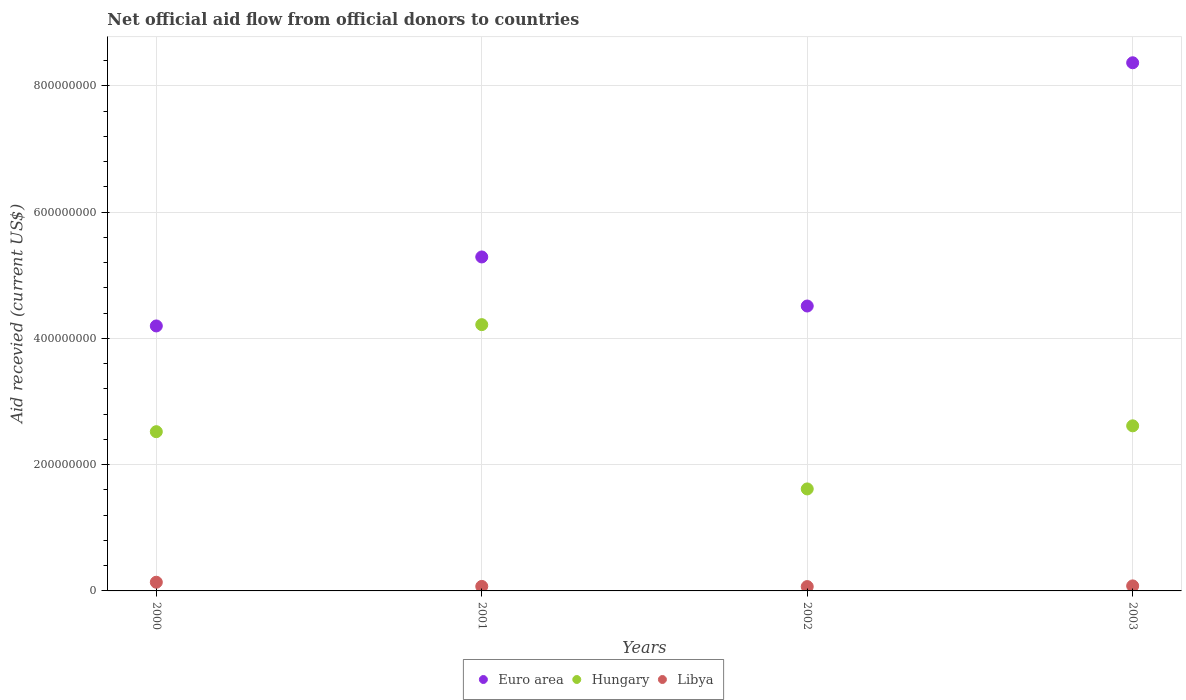How many different coloured dotlines are there?
Ensure brevity in your answer.  3. What is the total aid received in Libya in 2003?
Provide a short and direct response. 7.95e+06. Across all years, what is the maximum total aid received in Euro area?
Ensure brevity in your answer.  8.36e+08. Across all years, what is the minimum total aid received in Libya?
Offer a terse response. 6.88e+06. What is the total total aid received in Hungary in the graph?
Provide a succinct answer. 1.10e+09. What is the difference between the total aid received in Euro area in 2002 and that in 2003?
Provide a short and direct response. -3.85e+08. What is the difference between the total aid received in Euro area in 2003 and the total aid received in Hungary in 2000?
Provide a short and direct response. 5.84e+08. What is the average total aid received in Libya per year?
Ensure brevity in your answer.  8.93e+06. In the year 2000, what is the difference between the total aid received in Libya and total aid received in Hungary?
Keep it short and to the point. -2.38e+08. What is the ratio of the total aid received in Euro area in 2001 to that in 2003?
Your response must be concise. 0.63. Is the difference between the total aid received in Libya in 2000 and 2002 greater than the difference between the total aid received in Hungary in 2000 and 2002?
Keep it short and to the point. No. What is the difference between the highest and the second highest total aid received in Euro area?
Your answer should be compact. 3.08e+08. What is the difference between the highest and the lowest total aid received in Euro area?
Keep it short and to the point. 4.17e+08. In how many years, is the total aid received in Hungary greater than the average total aid received in Hungary taken over all years?
Provide a succinct answer. 1. Is the sum of the total aid received in Euro area in 2002 and 2003 greater than the maximum total aid received in Hungary across all years?
Give a very brief answer. Yes. Does the total aid received in Libya monotonically increase over the years?
Offer a terse response. No. How many years are there in the graph?
Provide a short and direct response. 4. What is the difference between two consecutive major ticks on the Y-axis?
Offer a terse response. 2.00e+08. Are the values on the major ticks of Y-axis written in scientific E-notation?
Make the answer very short. No. Does the graph contain grids?
Provide a succinct answer. Yes. Where does the legend appear in the graph?
Give a very brief answer. Bottom center. What is the title of the graph?
Your answer should be very brief. Net official aid flow from official donors to countries. Does "High income: nonOECD" appear as one of the legend labels in the graph?
Provide a succinct answer. No. What is the label or title of the X-axis?
Provide a short and direct response. Years. What is the label or title of the Y-axis?
Make the answer very short. Aid recevied (current US$). What is the Aid recevied (current US$) of Euro area in 2000?
Ensure brevity in your answer.  4.20e+08. What is the Aid recevied (current US$) of Hungary in 2000?
Offer a very short reply. 2.52e+08. What is the Aid recevied (current US$) in Libya in 2000?
Your response must be concise. 1.38e+07. What is the Aid recevied (current US$) of Euro area in 2001?
Make the answer very short. 5.29e+08. What is the Aid recevied (current US$) in Hungary in 2001?
Your answer should be very brief. 4.22e+08. What is the Aid recevied (current US$) in Libya in 2001?
Provide a short and direct response. 7.14e+06. What is the Aid recevied (current US$) of Euro area in 2002?
Give a very brief answer. 4.51e+08. What is the Aid recevied (current US$) in Hungary in 2002?
Offer a terse response. 1.62e+08. What is the Aid recevied (current US$) of Libya in 2002?
Give a very brief answer. 6.88e+06. What is the Aid recevied (current US$) in Euro area in 2003?
Your answer should be very brief. 8.36e+08. What is the Aid recevied (current US$) of Hungary in 2003?
Your answer should be compact. 2.61e+08. What is the Aid recevied (current US$) of Libya in 2003?
Provide a short and direct response. 7.95e+06. Across all years, what is the maximum Aid recevied (current US$) in Euro area?
Offer a terse response. 8.36e+08. Across all years, what is the maximum Aid recevied (current US$) in Hungary?
Provide a short and direct response. 4.22e+08. Across all years, what is the maximum Aid recevied (current US$) in Libya?
Ensure brevity in your answer.  1.38e+07. Across all years, what is the minimum Aid recevied (current US$) of Euro area?
Ensure brevity in your answer.  4.20e+08. Across all years, what is the minimum Aid recevied (current US$) in Hungary?
Provide a short and direct response. 1.62e+08. Across all years, what is the minimum Aid recevied (current US$) of Libya?
Your response must be concise. 6.88e+06. What is the total Aid recevied (current US$) of Euro area in the graph?
Offer a very short reply. 2.24e+09. What is the total Aid recevied (current US$) of Hungary in the graph?
Make the answer very short. 1.10e+09. What is the total Aid recevied (current US$) in Libya in the graph?
Give a very brief answer. 3.57e+07. What is the difference between the Aid recevied (current US$) in Euro area in 2000 and that in 2001?
Give a very brief answer. -1.09e+08. What is the difference between the Aid recevied (current US$) of Hungary in 2000 and that in 2001?
Your answer should be compact. -1.70e+08. What is the difference between the Aid recevied (current US$) in Libya in 2000 and that in 2001?
Make the answer very short. 6.61e+06. What is the difference between the Aid recevied (current US$) of Euro area in 2000 and that in 2002?
Give a very brief answer. -3.16e+07. What is the difference between the Aid recevied (current US$) of Hungary in 2000 and that in 2002?
Provide a short and direct response. 9.06e+07. What is the difference between the Aid recevied (current US$) in Libya in 2000 and that in 2002?
Keep it short and to the point. 6.87e+06. What is the difference between the Aid recevied (current US$) of Euro area in 2000 and that in 2003?
Your response must be concise. -4.17e+08. What is the difference between the Aid recevied (current US$) in Hungary in 2000 and that in 2003?
Provide a succinct answer. -9.28e+06. What is the difference between the Aid recevied (current US$) of Libya in 2000 and that in 2003?
Your answer should be very brief. 5.80e+06. What is the difference between the Aid recevied (current US$) in Euro area in 2001 and that in 2002?
Provide a succinct answer. 7.77e+07. What is the difference between the Aid recevied (current US$) in Hungary in 2001 and that in 2002?
Your response must be concise. 2.60e+08. What is the difference between the Aid recevied (current US$) in Euro area in 2001 and that in 2003?
Offer a terse response. -3.08e+08. What is the difference between the Aid recevied (current US$) of Hungary in 2001 and that in 2003?
Ensure brevity in your answer.  1.60e+08. What is the difference between the Aid recevied (current US$) in Libya in 2001 and that in 2003?
Give a very brief answer. -8.10e+05. What is the difference between the Aid recevied (current US$) in Euro area in 2002 and that in 2003?
Keep it short and to the point. -3.85e+08. What is the difference between the Aid recevied (current US$) in Hungary in 2002 and that in 2003?
Offer a terse response. -9.99e+07. What is the difference between the Aid recevied (current US$) in Libya in 2002 and that in 2003?
Provide a succinct answer. -1.07e+06. What is the difference between the Aid recevied (current US$) of Euro area in 2000 and the Aid recevied (current US$) of Hungary in 2001?
Your answer should be compact. -2.06e+06. What is the difference between the Aid recevied (current US$) of Euro area in 2000 and the Aid recevied (current US$) of Libya in 2001?
Give a very brief answer. 4.12e+08. What is the difference between the Aid recevied (current US$) in Hungary in 2000 and the Aid recevied (current US$) in Libya in 2001?
Give a very brief answer. 2.45e+08. What is the difference between the Aid recevied (current US$) of Euro area in 2000 and the Aid recevied (current US$) of Hungary in 2002?
Offer a very short reply. 2.58e+08. What is the difference between the Aid recevied (current US$) in Euro area in 2000 and the Aid recevied (current US$) in Libya in 2002?
Provide a succinct answer. 4.13e+08. What is the difference between the Aid recevied (current US$) in Hungary in 2000 and the Aid recevied (current US$) in Libya in 2002?
Your answer should be compact. 2.45e+08. What is the difference between the Aid recevied (current US$) of Euro area in 2000 and the Aid recevied (current US$) of Hungary in 2003?
Offer a terse response. 1.58e+08. What is the difference between the Aid recevied (current US$) of Euro area in 2000 and the Aid recevied (current US$) of Libya in 2003?
Your answer should be very brief. 4.12e+08. What is the difference between the Aid recevied (current US$) of Hungary in 2000 and the Aid recevied (current US$) of Libya in 2003?
Offer a very short reply. 2.44e+08. What is the difference between the Aid recevied (current US$) in Euro area in 2001 and the Aid recevied (current US$) in Hungary in 2002?
Keep it short and to the point. 3.67e+08. What is the difference between the Aid recevied (current US$) in Euro area in 2001 and the Aid recevied (current US$) in Libya in 2002?
Provide a short and direct response. 5.22e+08. What is the difference between the Aid recevied (current US$) in Hungary in 2001 and the Aid recevied (current US$) in Libya in 2002?
Your answer should be compact. 4.15e+08. What is the difference between the Aid recevied (current US$) in Euro area in 2001 and the Aid recevied (current US$) in Hungary in 2003?
Give a very brief answer. 2.67e+08. What is the difference between the Aid recevied (current US$) in Euro area in 2001 and the Aid recevied (current US$) in Libya in 2003?
Keep it short and to the point. 5.21e+08. What is the difference between the Aid recevied (current US$) in Hungary in 2001 and the Aid recevied (current US$) in Libya in 2003?
Make the answer very short. 4.14e+08. What is the difference between the Aid recevied (current US$) of Euro area in 2002 and the Aid recevied (current US$) of Hungary in 2003?
Keep it short and to the point. 1.90e+08. What is the difference between the Aid recevied (current US$) of Euro area in 2002 and the Aid recevied (current US$) of Libya in 2003?
Your answer should be very brief. 4.43e+08. What is the difference between the Aid recevied (current US$) in Hungary in 2002 and the Aid recevied (current US$) in Libya in 2003?
Make the answer very short. 1.54e+08. What is the average Aid recevied (current US$) in Euro area per year?
Make the answer very short. 5.59e+08. What is the average Aid recevied (current US$) in Hungary per year?
Provide a short and direct response. 2.74e+08. What is the average Aid recevied (current US$) in Libya per year?
Your answer should be very brief. 8.93e+06. In the year 2000, what is the difference between the Aid recevied (current US$) in Euro area and Aid recevied (current US$) in Hungary?
Your answer should be very brief. 1.67e+08. In the year 2000, what is the difference between the Aid recevied (current US$) in Euro area and Aid recevied (current US$) in Libya?
Offer a very short reply. 4.06e+08. In the year 2000, what is the difference between the Aid recevied (current US$) in Hungary and Aid recevied (current US$) in Libya?
Provide a succinct answer. 2.38e+08. In the year 2001, what is the difference between the Aid recevied (current US$) of Euro area and Aid recevied (current US$) of Hungary?
Offer a very short reply. 1.07e+08. In the year 2001, what is the difference between the Aid recevied (current US$) of Euro area and Aid recevied (current US$) of Libya?
Provide a succinct answer. 5.22e+08. In the year 2001, what is the difference between the Aid recevied (current US$) in Hungary and Aid recevied (current US$) in Libya?
Offer a very short reply. 4.15e+08. In the year 2002, what is the difference between the Aid recevied (current US$) of Euro area and Aid recevied (current US$) of Hungary?
Offer a very short reply. 2.90e+08. In the year 2002, what is the difference between the Aid recevied (current US$) of Euro area and Aid recevied (current US$) of Libya?
Offer a terse response. 4.44e+08. In the year 2002, what is the difference between the Aid recevied (current US$) of Hungary and Aid recevied (current US$) of Libya?
Provide a short and direct response. 1.55e+08. In the year 2003, what is the difference between the Aid recevied (current US$) in Euro area and Aid recevied (current US$) in Hungary?
Your response must be concise. 5.75e+08. In the year 2003, what is the difference between the Aid recevied (current US$) in Euro area and Aid recevied (current US$) in Libya?
Your answer should be very brief. 8.28e+08. In the year 2003, what is the difference between the Aid recevied (current US$) in Hungary and Aid recevied (current US$) in Libya?
Give a very brief answer. 2.54e+08. What is the ratio of the Aid recevied (current US$) in Euro area in 2000 to that in 2001?
Your response must be concise. 0.79. What is the ratio of the Aid recevied (current US$) in Hungary in 2000 to that in 2001?
Keep it short and to the point. 0.6. What is the ratio of the Aid recevied (current US$) of Libya in 2000 to that in 2001?
Keep it short and to the point. 1.93. What is the ratio of the Aid recevied (current US$) in Euro area in 2000 to that in 2002?
Keep it short and to the point. 0.93. What is the ratio of the Aid recevied (current US$) in Hungary in 2000 to that in 2002?
Provide a short and direct response. 1.56. What is the ratio of the Aid recevied (current US$) of Libya in 2000 to that in 2002?
Provide a succinct answer. 2. What is the ratio of the Aid recevied (current US$) of Euro area in 2000 to that in 2003?
Offer a terse response. 0.5. What is the ratio of the Aid recevied (current US$) in Hungary in 2000 to that in 2003?
Keep it short and to the point. 0.96. What is the ratio of the Aid recevied (current US$) in Libya in 2000 to that in 2003?
Ensure brevity in your answer.  1.73. What is the ratio of the Aid recevied (current US$) of Euro area in 2001 to that in 2002?
Keep it short and to the point. 1.17. What is the ratio of the Aid recevied (current US$) of Hungary in 2001 to that in 2002?
Ensure brevity in your answer.  2.61. What is the ratio of the Aid recevied (current US$) of Libya in 2001 to that in 2002?
Make the answer very short. 1.04. What is the ratio of the Aid recevied (current US$) of Euro area in 2001 to that in 2003?
Provide a short and direct response. 0.63. What is the ratio of the Aid recevied (current US$) of Hungary in 2001 to that in 2003?
Provide a short and direct response. 1.61. What is the ratio of the Aid recevied (current US$) of Libya in 2001 to that in 2003?
Make the answer very short. 0.9. What is the ratio of the Aid recevied (current US$) in Euro area in 2002 to that in 2003?
Ensure brevity in your answer.  0.54. What is the ratio of the Aid recevied (current US$) of Hungary in 2002 to that in 2003?
Your answer should be very brief. 0.62. What is the ratio of the Aid recevied (current US$) of Libya in 2002 to that in 2003?
Provide a short and direct response. 0.87. What is the difference between the highest and the second highest Aid recevied (current US$) in Euro area?
Keep it short and to the point. 3.08e+08. What is the difference between the highest and the second highest Aid recevied (current US$) in Hungary?
Offer a very short reply. 1.60e+08. What is the difference between the highest and the second highest Aid recevied (current US$) of Libya?
Offer a very short reply. 5.80e+06. What is the difference between the highest and the lowest Aid recevied (current US$) of Euro area?
Offer a terse response. 4.17e+08. What is the difference between the highest and the lowest Aid recevied (current US$) of Hungary?
Offer a very short reply. 2.60e+08. What is the difference between the highest and the lowest Aid recevied (current US$) in Libya?
Make the answer very short. 6.87e+06. 